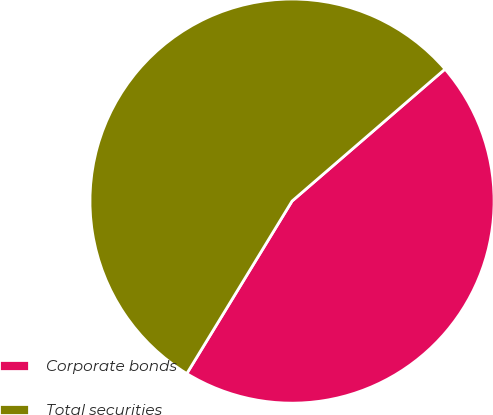Convert chart to OTSL. <chart><loc_0><loc_0><loc_500><loc_500><pie_chart><fcel>Corporate bonds<fcel>Total securities<nl><fcel>45.05%<fcel>54.95%<nl></chart> 